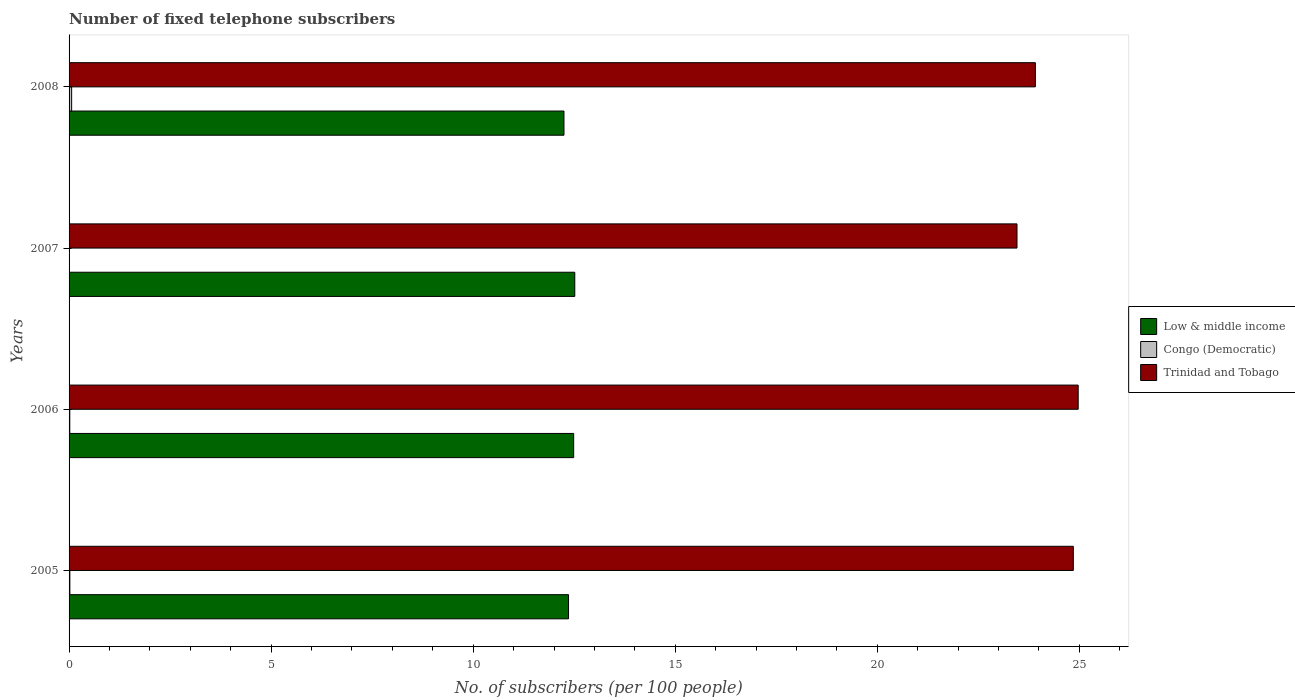How many different coloured bars are there?
Your answer should be compact. 3. How many groups of bars are there?
Your response must be concise. 4. Are the number of bars per tick equal to the number of legend labels?
Your response must be concise. Yes. Are the number of bars on each tick of the Y-axis equal?
Your answer should be compact. Yes. How many bars are there on the 4th tick from the bottom?
Your answer should be compact. 3. In how many cases, is the number of bars for a given year not equal to the number of legend labels?
Ensure brevity in your answer.  0. What is the number of fixed telephone subscribers in Trinidad and Tobago in 2008?
Give a very brief answer. 23.91. Across all years, what is the maximum number of fixed telephone subscribers in Low & middle income?
Keep it short and to the point. 12.51. Across all years, what is the minimum number of fixed telephone subscribers in Trinidad and Tobago?
Ensure brevity in your answer.  23.46. In which year was the number of fixed telephone subscribers in Congo (Democratic) minimum?
Ensure brevity in your answer.  2007. What is the total number of fixed telephone subscribers in Trinidad and Tobago in the graph?
Make the answer very short. 97.19. What is the difference between the number of fixed telephone subscribers in Congo (Democratic) in 2006 and that in 2008?
Your response must be concise. -0.05. What is the difference between the number of fixed telephone subscribers in Trinidad and Tobago in 2005 and the number of fixed telephone subscribers in Low & middle income in 2008?
Make the answer very short. 12.6. What is the average number of fixed telephone subscribers in Trinidad and Tobago per year?
Make the answer very short. 24.3. In the year 2007, what is the difference between the number of fixed telephone subscribers in Trinidad and Tobago and number of fixed telephone subscribers in Low & middle income?
Keep it short and to the point. 10.94. In how many years, is the number of fixed telephone subscribers in Congo (Democratic) greater than 21 ?
Ensure brevity in your answer.  0. What is the ratio of the number of fixed telephone subscribers in Low & middle income in 2005 to that in 2007?
Provide a succinct answer. 0.99. Is the difference between the number of fixed telephone subscribers in Trinidad and Tobago in 2005 and 2006 greater than the difference between the number of fixed telephone subscribers in Low & middle income in 2005 and 2006?
Offer a very short reply. Yes. What is the difference between the highest and the second highest number of fixed telephone subscribers in Low & middle income?
Ensure brevity in your answer.  0.03. What is the difference between the highest and the lowest number of fixed telephone subscribers in Congo (Democratic)?
Offer a terse response. 0.06. Is the sum of the number of fixed telephone subscribers in Low & middle income in 2005 and 2008 greater than the maximum number of fixed telephone subscribers in Congo (Democratic) across all years?
Make the answer very short. Yes. What does the 3rd bar from the top in 2005 represents?
Provide a short and direct response. Low & middle income. What does the 3rd bar from the bottom in 2006 represents?
Your answer should be compact. Trinidad and Tobago. How many bars are there?
Your answer should be very brief. 12. Does the graph contain any zero values?
Keep it short and to the point. No. How many legend labels are there?
Keep it short and to the point. 3. What is the title of the graph?
Provide a short and direct response. Number of fixed telephone subscribers. Does "Uruguay" appear as one of the legend labels in the graph?
Your response must be concise. No. What is the label or title of the X-axis?
Ensure brevity in your answer.  No. of subscribers (per 100 people). What is the label or title of the Y-axis?
Offer a terse response. Years. What is the No. of subscribers (per 100 people) in Low & middle income in 2005?
Provide a short and direct response. 12.36. What is the No. of subscribers (per 100 people) of Congo (Democratic) in 2005?
Your answer should be very brief. 0.02. What is the No. of subscribers (per 100 people) of Trinidad and Tobago in 2005?
Provide a succinct answer. 24.85. What is the No. of subscribers (per 100 people) of Low & middle income in 2006?
Ensure brevity in your answer.  12.49. What is the No. of subscribers (per 100 people) of Congo (Democratic) in 2006?
Offer a very short reply. 0.02. What is the No. of subscribers (per 100 people) of Trinidad and Tobago in 2006?
Offer a terse response. 24.97. What is the No. of subscribers (per 100 people) in Low & middle income in 2007?
Your response must be concise. 12.51. What is the No. of subscribers (per 100 people) in Congo (Democratic) in 2007?
Provide a succinct answer. 0.01. What is the No. of subscribers (per 100 people) in Trinidad and Tobago in 2007?
Keep it short and to the point. 23.46. What is the No. of subscribers (per 100 people) of Low & middle income in 2008?
Your answer should be compact. 12.25. What is the No. of subscribers (per 100 people) of Congo (Democratic) in 2008?
Offer a terse response. 0.06. What is the No. of subscribers (per 100 people) in Trinidad and Tobago in 2008?
Keep it short and to the point. 23.91. Across all years, what is the maximum No. of subscribers (per 100 people) of Low & middle income?
Your answer should be very brief. 12.51. Across all years, what is the maximum No. of subscribers (per 100 people) in Congo (Democratic)?
Your answer should be compact. 0.06. Across all years, what is the maximum No. of subscribers (per 100 people) in Trinidad and Tobago?
Your answer should be compact. 24.97. Across all years, what is the minimum No. of subscribers (per 100 people) of Low & middle income?
Keep it short and to the point. 12.25. Across all years, what is the minimum No. of subscribers (per 100 people) in Congo (Democratic)?
Offer a very short reply. 0.01. Across all years, what is the minimum No. of subscribers (per 100 people) of Trinidad and Tobago?
Make the answer very short. 23.46. What is the total No. of subscribers (per 100 people) in Low & middle income in the graph?
Offer a very short reply. 49.61. What is the total No. of subscribers (per 100 people) of Congo (Democratic) in the graph?
Ensure brevity in your answer.  0.11. What is the total No. of subscribers (per 100 people) of Trinidad and Tobago in the graph?
Keep it short and to the point. 97.19. What is the difference between the No. of subscribers (per 100 people) in Low & middle income in 2005 and that in 2006?
Give a very brief answer. -0.13. What is the difference between the No. of subscribers (per 100 people) of Congo (Democratic) in 2005 and that in 2006?
Your answer should be compact. 0. What is the difference between the No. of subscribers (per 100 people) in Trinidad and Tobago in 2005 and that in 2006?
Your answer should be compact. -0.12. What is the difference between the No. of subscribers (per 100 people) of Low & middle income in 2005 and that in 2007?
Offer a very short reply. -0.15. What is the difference between the No. of subscribers (per 100 people) of Congo (Democratic) in 2005 and that in 2007?
Keep it short and to the point. 0.01. What is the difference between the No. of subscribers (per 100 people) of Trinidad and Tobago in 2005 and that in 2007?
Your answer should be compact. 1.39. What is the difference between the No. of subscribers (per 100 people) in Low & middle income in 2005 and that in 2008?
Ensure brevity in your answer.  0.11. What is the difference between the No. of subscribers (per 100 people) in Congo (Democratic) in 2005 and that in 2008?
Your response must be concise. -0.04. What is the difference between the No. of subscribers (per 100 people) in Trinidad and Tobago in 2005 and that in 2008?
Offer a terse response. 0.94. What is the difference between the No. of subscribers (per 100 people) of Low & middle income in 2006 and that in 2007?
Make the answer very short. -0.03. What is the difference between the No. of subscribers (per 100 people) in Congo (Democratic) in 2006 and that in 2007?
Ensure brevity in your answer.  0.01. What is the difference between the No. of subscribers (per 100 people) in Trinidad and Tobago in 2006 and that in 2007?
Provide a succinct answer. 1.51. What is the difference between the No. of subscribers (per 100 people) of Low & middle income in 2006 and that in 2008?
Make the answer very short. 0.24. What is the difference between the No. of subscribers (per 100 people) of Congo (Democratic) in 2006 and that in 2008?
Your answer should be compact. -0.05. What is the difference between the No. of subscribers (per 100 people) of Trinidad and Tobago in 2006 and that in 2008?
Your answer should be compact. 1.06. What is the difference between the No. of subscribers (per 100 people) of Low & middle income in 2007 and that in 2008?
Offer a very short reply. 0.27. What is the difference between the No. of subscribers (per 100 people) in Congo (Democratic) in 2007 and that in 2008?
Ensure brevity in your answer.  -0.06. What is the difference between the No. of subscribers (per 100 people) in Trinidad and Tobago in 2007 and that in 2008?
Give a very brief answer. -0.45. What is the difference between the No. of subscribers (per 100 people) of Low & middle income in 2005 and the No. of subscribers (per 100 people) of Congo (Democratic) in 2006?
Give a very brief answer. 12.34. What is the difference between the No. of subscribers (per 100 people) in Low & middle income in 2005 and the No. of subscribers (per 100 people) in Trinidad and Tobago in 2006?
Offer a very short reply. -12.61. What is the difference between the No. of subscribers (per 100 people) in Congo (Democratic) in 2005 and the No. of subscribers (per 100 people) in Trinidad and Tobago in 2006?
Give a very brief answer. -24.95. What is the difference between the No. of subscribers (per 100 people) in Low & middle income in 2005 and the No. of subscribers (per 100 people) in Congo (Democratic) in 2007?
Your answer should be very brief. 12.35. What is the difference between the No. of subscribers (per 100 people) of Low & middle income in 2005 and the No. of subscribers (per 100 people) of Trinidad and Tobago in 2007?
Keep it short and to the point. -11.1. What is the difference between the No. of subscribers (per 100 people) of Congo (Democratic) in 2005 and the No. of subscribers (per 100 people) of Trinidad and Tobago in 2007?
Offer a terse response. -23.44. What is the difference between the No. of subscribers (per 100 people) of Low & middle income in 2005 and the No. of subscribers (per 100 people) of Congo (Democratic) in 2008?
Provide a short and direct response. 12.3. What is the difference between the No. of subscribers (per 100 people) of Low & middle income in 2005 and the No. of subscribers (per 100 people) of Trinidad and Tobago in 2008?
Give a very brief answer. -11.55. What is the difference between the No. of subscribers (per 100 people) in Congo (Democratic) in 2005 and the No. of subscribers (per 100 people) in Trinidad and Tobago in 2008?
Make the answer very short. -23.89. What is the difference between the No. of subscribers (per 100 people) of Low & middle income in 2006 and the No. of subscribers (per 100 people) of Congo (Democratic) in 2007?
Your answer should be very brief. 12.48. What is the difference between the No. of subscribers (per 100 people) in Low & middle income in 2006 and the No. of subscribers (per 100 people) in Trinidad and Tobago in 2007?
Your answer should be very brief. -10.97. What is the difference between the No. of subscribers (per 100 people) of Congo (Democratic) in 2006 and the No. of subscribers (per 100 people) of Trinidad and Tobago in 2007?
Make the answer very short. -23.44. What is the difference between the No. of subscribers (per 100 people) in Low & middle income in 2006 and the No. of subscribers (per 100 people) in Congo (Democratic) in 2008?
Give a very brief answer. 12.42. What is the difference between the No. of subscribers (per 100 people) of Low & middle income in 2006 and the No. of subscribers (per 100 people) of Trinidad and Tobago in 2008?
Offer a very short reply. -11.43. What is the difference between the No. of subscribers (per 100 people) in Congo (Democratic) in 2006 and the No. of subscribers (per 100 people) in Trinidad and Tobago in 2008?
Offer a terse response. -23.89. What is the difference between the No. of subscribers (per 100 people) of Low & middle income in 2007 and the No. of subscribers (per 100 people) of Congo (Democratic) in 2008?
Offer a very short reply. 12.45. What is the difference between the No. of subscribers (per 100 people) of Low & middle income in 2007 and the No. of subscribers (per 100 people) of Trinidad and Tobago in 2008?
Keep it short and to the point. -11.4. What is the difference between the No. of subscribers (per 100 people) in Congo (Democratic) in 2007 and the No. of subscribers (per 100 people) in Trinidad and Tobago in 2008?
Your answer should be compact. -23.91. What is the average No. of subscribers (per 100 people) in Low & middle income per year?
Keep it short and to the point. 12.4. What is the average No. of subscribers (per 100 people) of Congo (Democratic) per year?
Make the answer very short. 0.03. What is the average No. of subscribers (per 100 people) in Trinidad and Tobago per year?
Keep it short and to the point. 24.3. In the year 2005, what is the difference between the No. of subscribers (per 100 people) of Low & middle income and No. of subscribers (per 100 people) of Congo (Democratic)?
Provide a short and direct response. 12.34. In the year 2005, what is the difference between the No. of subscribers (per 100 people) of Low & middle income and No. of subscribers (per 100 people) of Trinidad and Tobago?
Provide a short and direct response. -12.49. In the year 2005, what is the difference between the No. of subscribers (per 100 people) in Congo (Democratic) and No. of subscribers (per 100 people) in Trinidad and Tobago?
Make the answer very short. -24.83. In the year 2006, what is the difference between the No. of subscribers (per 100 people) of Low & middle income and No. of subscribers (per 100 people) of Congo (Democratic)?
Give a very brief answer. 12.47. In the year 2006, what is the difference between the No. of subscribers (per 100 people) in Low & middle income and No. of subscribers (per 100 people) in Trinidad and Tobago?
Provide a short and direct response. -12.48. In the year 2006, what is the difference between the No. of subscribers (per 100 people) in Congo (Democratic) and No. of subscribers (per 100 people) in Trinidad and Tobago?
Ensure brevity in your answer.  -24.95. In the year 2007, what is the difference between the No. of subscribers (per 100 people) of Low & middle income and No. of subscribers (per 100 people) of Congo (Democratic)?
Give a very brief answer. 12.51. In the year 2007, what is the difference between the No. of subscribers (per 100 people) in Low & middle income and No. of subscribers (per 100 people) in Trinidad and Tobago?
Your answer should be compact. -10.94. In the year 2007, what is the difference between the No. of subscribers (per 100 people) of Congo (Democratic) and No. of subscribers (per 100 people) of Trinidad and Tobago?
Offer a very short reply. -23.45. In the year 2008, what is the difference between the No. of subscribers (per 100 people) of Low & middle income and No. of subscribers (per 100 people) of Congo (Democratic)?
Your answer should be very brief. 12.18. In the year 2008, what is the difference between the No. of subscribers (per 100 people) of Low & middle income and No. of subscribers (per 100 people) of Trinidad and Tobago?
Provide a short and direct response. -11.67. In the year 2008, what is the difference between the No. of subscribers (per 100 people) of Congo (Democratic) and No. of subscribers (per 100 people) of Trinidad and Tobago?
Keep it short and to the point. -23.85. What is the ratio of the No. of subscribers (per 100 people) in Congo (Democratic) in 2005 to that in 2006?
Your response must be concise. 1.12. What is the ratio of the No. of subscribers (per 100 people) in Trinidad and Tobago in 2005 to that in 2006?
Offer a very short reply. 1. What is the ratio of the No. of subscribers (per 100 people) in Low & middle income in 2005 to that in 2007?
Your answer should be very brief. 0.99. What is the ratio of the No. of subscribers (per 100 people) in Congo (Democratic) in 2005 to that in 2007?
Offer a terse response. 3.2. What is the ratio of the No. of subscribers (per 100 people) in Trinidad and Tobago in 2005 to that in 2007?
Keep it short and to the point. 1.06. What is the ratio of the No. of subscribers (per 100 people) of Low & middle income in 2005 to that in 2008?
Offer a terse response. 1.01. What is the ratio of the No. of subscribers (per 100 people) of Congo (Democratic) in 2005 to that in 2008?
Make the answer very short. 0.31. What is the ratio of the No. of subscribers (per 100 people) of Trinidad and Tobago in 2005 to that in 2008?
Offer a very short reply. 1.04. What is the ratio of the No. of subscribers (per 100 people) of Congo (Democratic) in 2006 to that in 2007?
Your answer should be very brief. 2.85. What is the ratio of the No. of subscribers (per 100 people) in Trinidad and Tobago in 2006 to that in 2007?
Offer a terse response. 1.06. What is the ratio of the No. of subscribers (per 100 people) in Low & middle income in 2006 to that in 2008?
Your answer should be very brief. 1.02. What is the ratio of the No. of subscribers (per 100 people) of Congo (Democratic) in 2006 to that in 2008?
Provide a succinct answer. 0.28. What is the ratio of the No. of subscribers (per 100 people) in Trinidad and Tobago in 2006 to that in 2008?
Your answer should be very brief. 1.04. What is the ratio of the No. of subscribers (per 100 people) in Low & middle income in 2007 to that in 2008?
Your answer should be very brief. 1.02. What is the ratio of the No. of subscribers (per 100 people) in Congo (Democratic) in 2007 to that in 2008?
Your response must be concise. 0.1. What is the ratio of the No. of subscribers (per 100 people) in Trinidad and Tobago in 2007 to that in 2008?
Provide a short and direct response. 0.98. What is the difference between the highest and the second highest No. of subscribers (per 100 people) in Low & middle income?
Your answer should be very brief. 0.03. What is the difference between the highest and the second highest No. of subscribers (per 100 people) in Congo (Democratic)?
Make the answer very short. 0.04. What is the difference between the highest and the second highest No. of subscribers (per 100 people) of Trinidad and Tobago?
Provide a succinct answer. 0.12. What is the difference between the highest and the lowest No. of subscribers (per 100 people) in Low & middle income?
Your answer should be very brief. 0.27. What is the difference between the highest and the lowest No. of subscribers (per 100 people) of Congo (Democratic)?
Ensure brevity in your answer.  0.06. What is the difference between the highest and the lowest No. of subscribers (per 100 people) in Trinidad and Tobago?
Give a very brief answer. 1.51. 